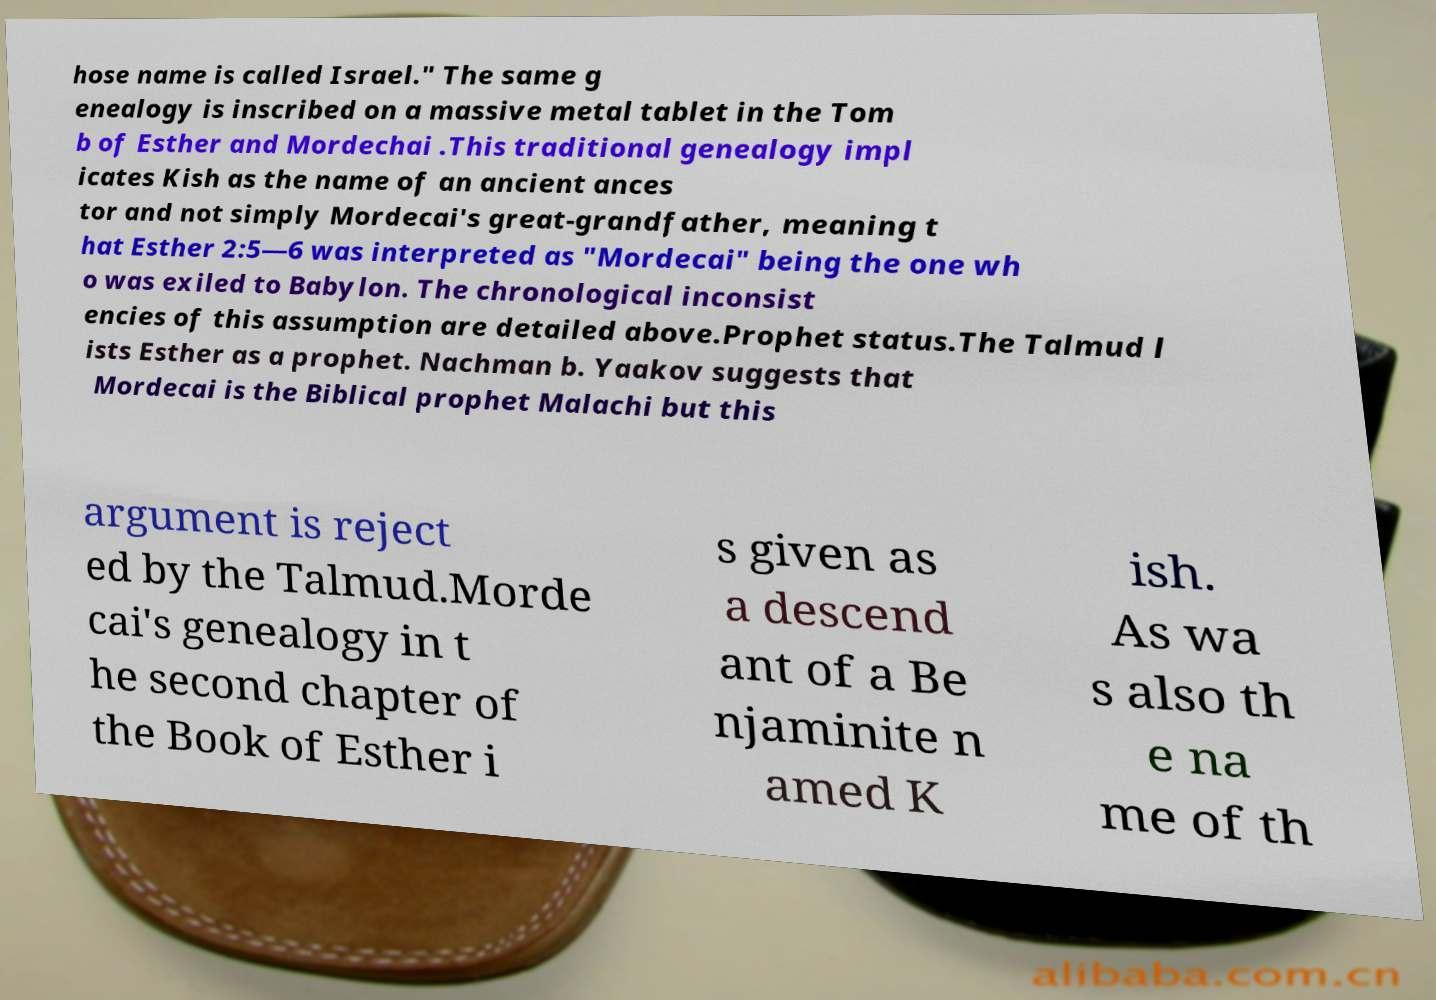Please identify and transcribe the text found in this image. hose name is called Israel." The same g enealogy is inscribed on a massive metal tablet in the Tom b of Esther and Mordechai .This traditional genealogy impl icates Kish as the name of an ancient ances tor and not simply Mordecai's great-grandfather, meaning t hat Esther 2:5—6 was interpreted as "Mordecai" being the one wh o was exiled to Babylon. The chronological inconsist encies of this assumption are detailed above.Prophet status.The Talmud l ists Esther as a prophet. Nachman b. Yaakov suggests that Mordecai is the Biblical prophet Malachi but this argument is reject ed by the Talmud.Morde cai's genealogy in t he second chapter of the Book of Esther i s given as a descend ant of a Be njaminite n amed K ish. As wa s also th e na me of th 